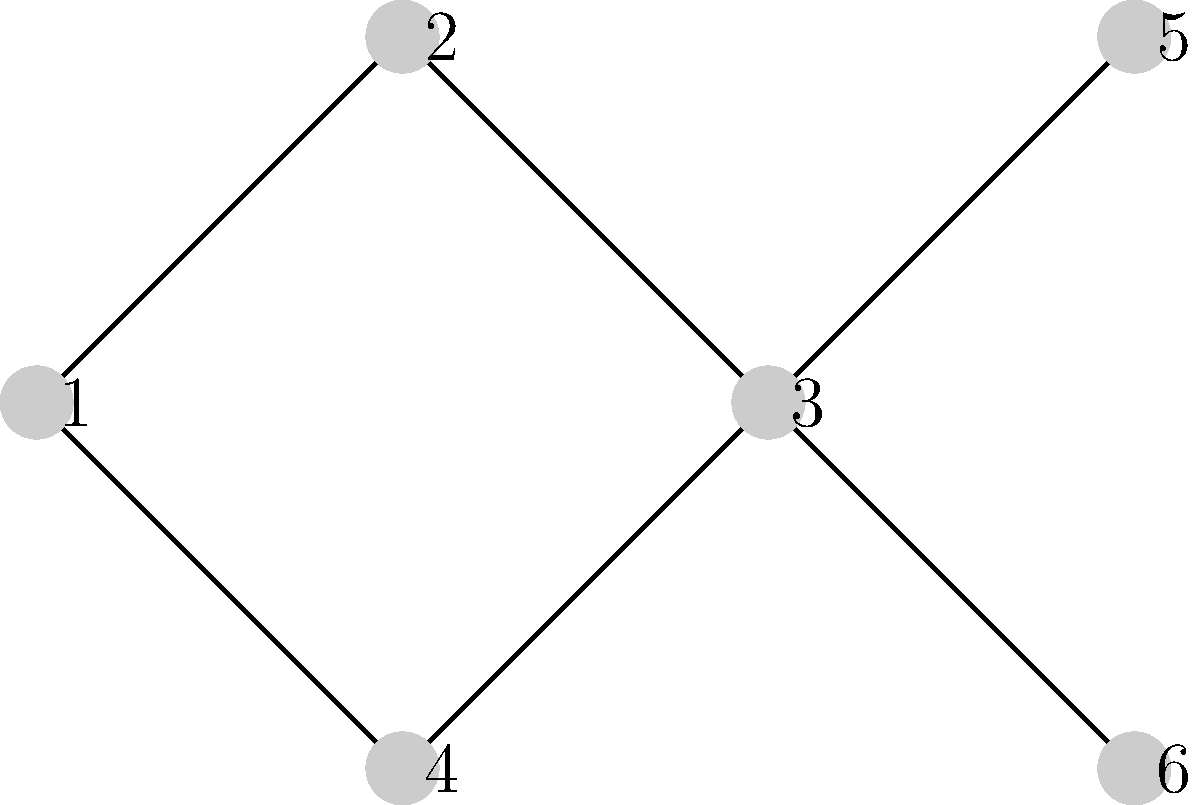A local wireless network provider is setting up a network in a small town. The diagram represents different access points, where each node is an access point, and edges indicate potential interference between nearby access points. Given that there are three available frequency bands, what is the minimum number of frequency bands needed to ensure no two adjacent access points use the same frequency? To solve this graph coloring problem, we'll follow these steps:

1. Understand the problem:
   - Each node represents an access point.
   - Edges represent potential interference.
   - We need to assign frequencies (colors) to minimize interference.

2. Analyze the graph structure:
   - The graph has 6 nodes and multiple edges.
   - We need to ensure no two adjacent nodes have the same color.

3. Apply the graph coloring algorithm:
   - Start with node 1 and assign it the first color.
   - Move to adjacent nodes and assign different colors.
   - Continue this process for all nodes.

4. Color assignment:
   - Node 1: Color 1
   - Node 2: Color 2 (adjacent to 1)
   - Node 3: Color 3 (adjacent to 2)
   - Node 4: Color 2 (adjacent to 1 and 3)
   - Node 5: Color 1 (adjacent to 2 and 3)
   - Node 6: Color 2 (adjacent to 3 and 5)

5. Verify the coloring:
   - No two adjacent nodes have the same color.
   - We used 3 colors in total.

6. Conclusion:
   The minimum number of frequency bands (colors) needed is 3.

This solution ensures that no two adjacent access points use the same frequency, minimizing interference in the local wireless network.
Answer: 3 frequency bands 